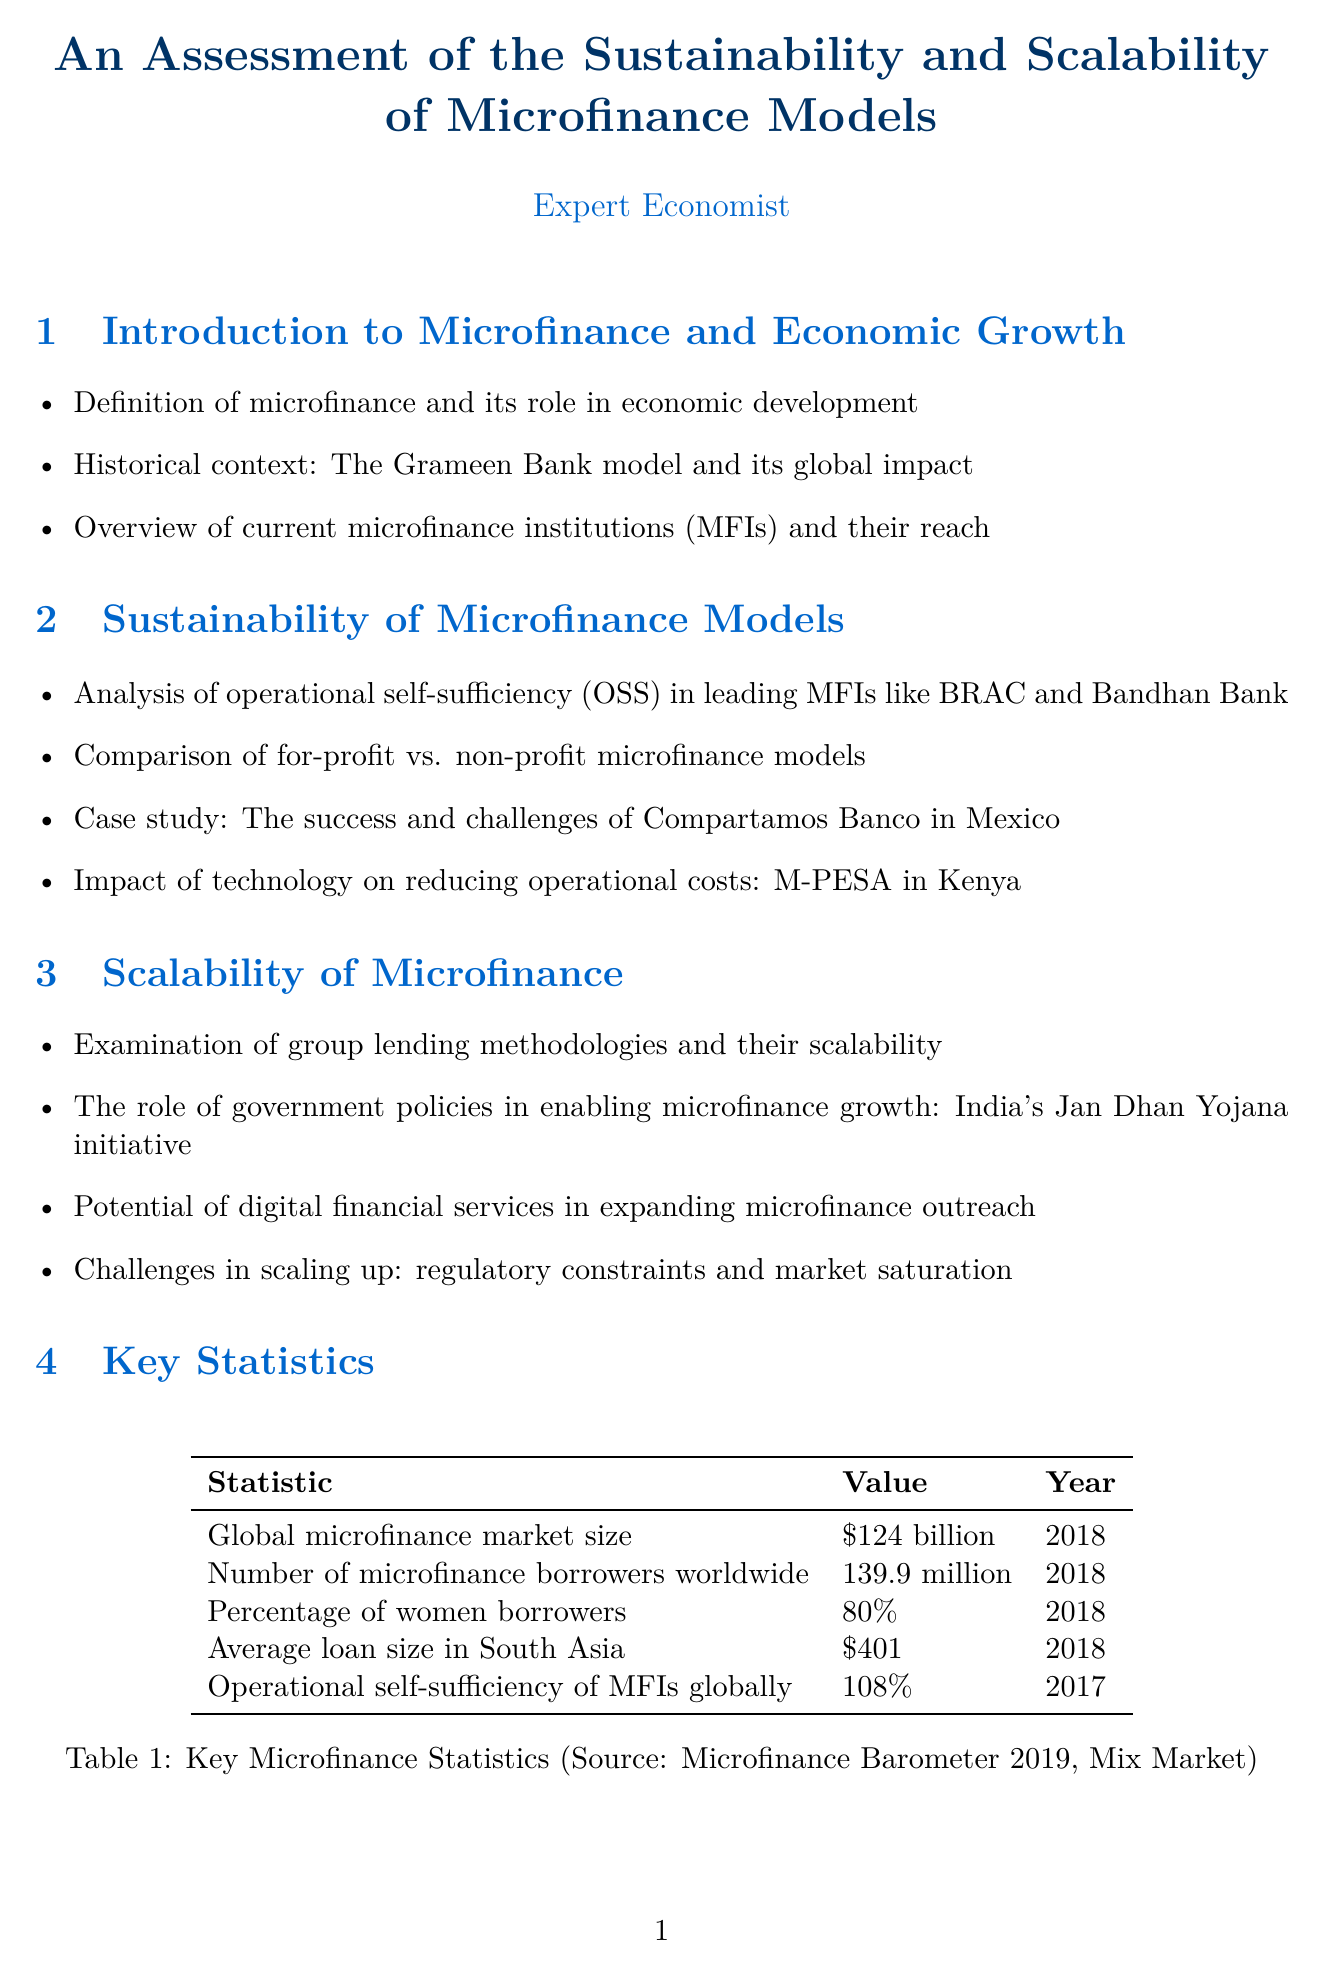What is the global microfinance market size? The global microfinance market size is provided in the key statistics section of the document.
Answer: $124 billion How many microfinance borrowers are there worldwide? The number of microfinance borrowers is listed in the key statistics section of the document.
Answer: 139.9 million What is the operational self-sufficiency of MFIs globally? The operational self-sufficiency is a statistic included in the document, reflecting the performance of MFIs.
Answer: 108% Who founded Grameen Bank? The document identifies Muhammad Yunus as the founder of Grameen Bank in the case studies section.
Answer: Muhammad Yunus What lending model did Grameen Bank pioneer? The lending model pioneered by Grameen Bank is noted in the case studies.
Answer: Group lending model What is one of the key risks in microfinance models discussed? The document elaborates on various risks in microfinance; one of them is specifically highlighted in the section on risks.
Answer: Over-indebtedness Which initiative in India helped enable microfinance growth? The role of government policies in enabling microfinance growth is showcased; one significant initiative is mentioned.
Answer: Jan Dhan Yojana What is the potential opportunity for future economic growth mentioned? The opportunities for future economic growth include various strategies highlighted in the document, one of which is specifically noted.
Answer: Green microfinance What type of loan does Banco Compartamos offer? The document includes information on Banco Compartamos, detailing the types of lending it provides.
Answer: Group and individual lending models 